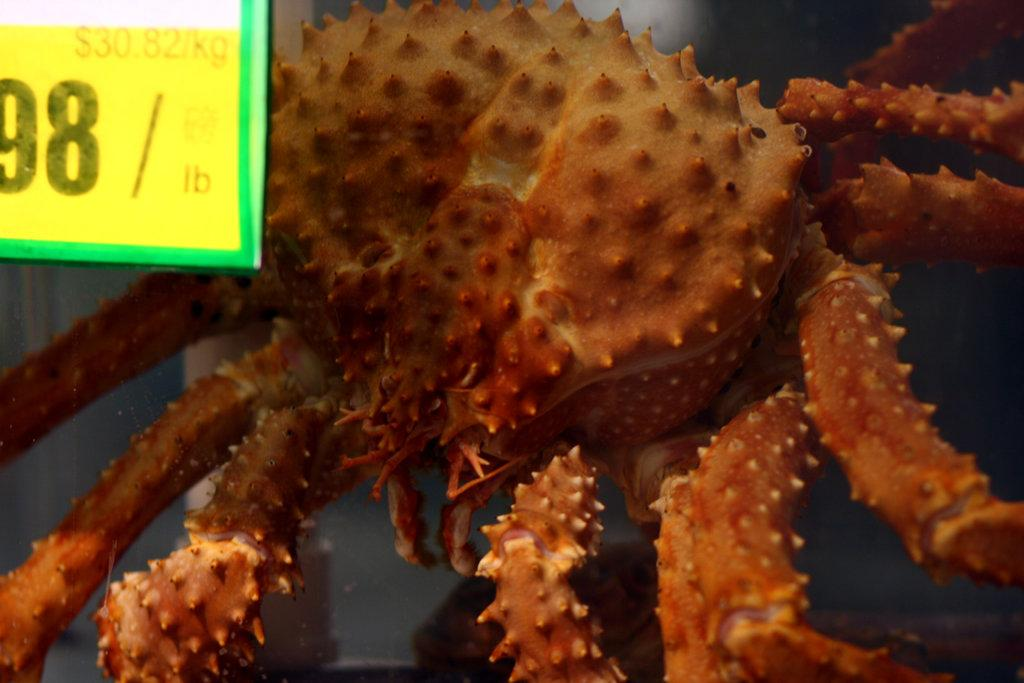What is the main subject of the image? The image has a crab-like appearance. Is there any additional information provided in the image? Yes, there is a price board in the top left corner of the image. What type of jewel can be seen on the crab's claw in the image? There is no jewel present on the crab's claw in the image. What scent is associated with the crab in the image? There is no mention of a scent in the image; it only has a crab-like appearance and a price board. 